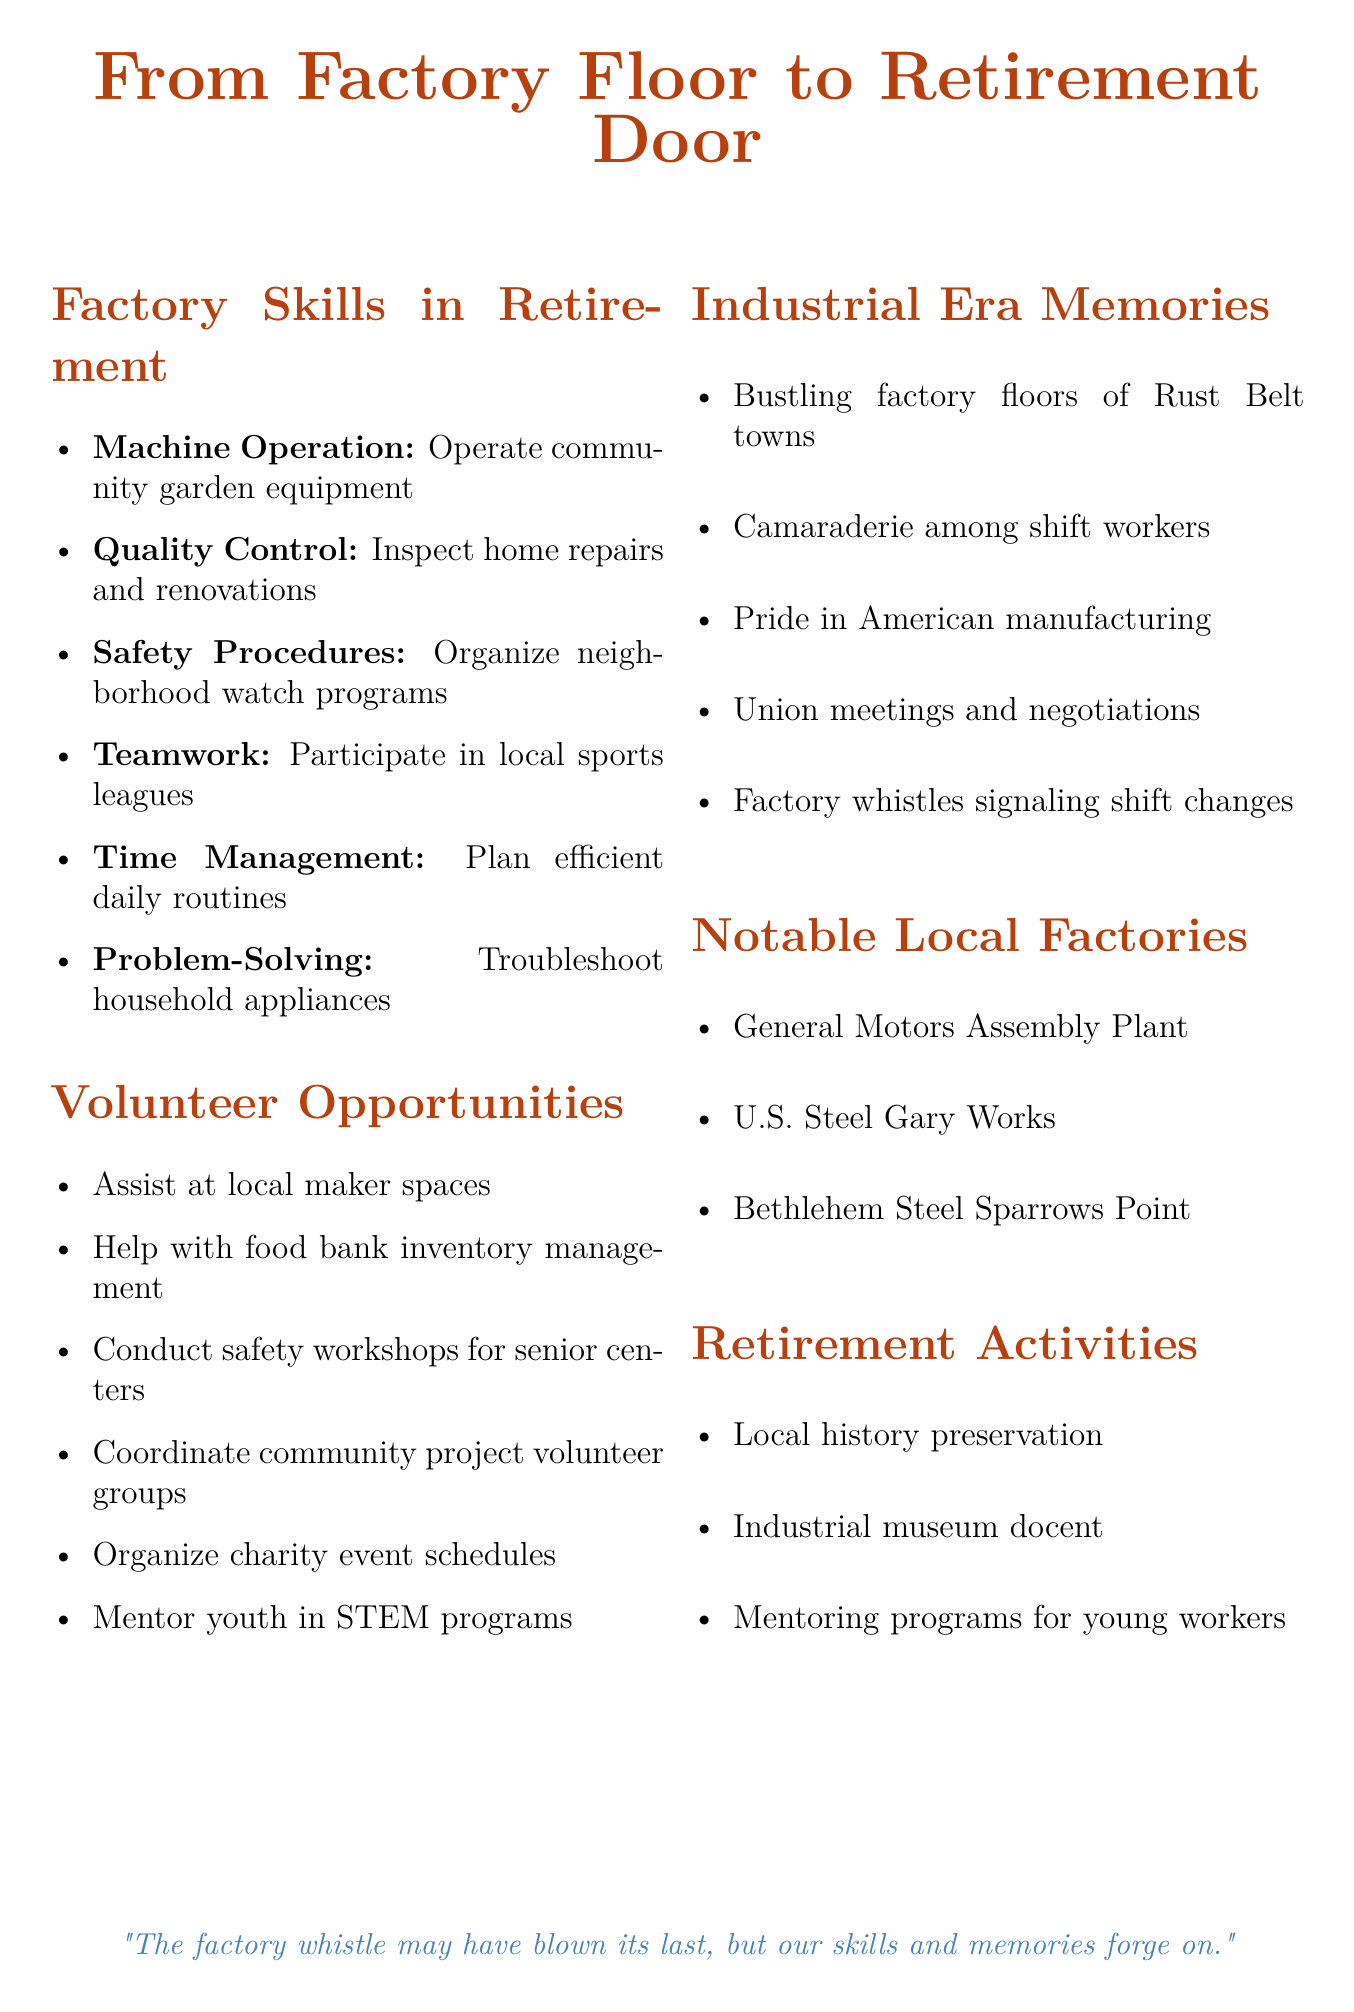What skill involves the use of equipment in community gardens? The skill that involves using equipment in community gardens is "Machine Operation."
Answer: Machine Operation What is one application of Quality Control in retirement? One application of Quality Control in retirement is "Inspecting home repairs and renovations."
Answer: Inspecting home repairs and renovations What type of workshops can seniors attend related to Safety Procedures? Seniors can attend "safety workshops" related to Safety Procedures.
Answer: safety workshops Which skill relates to helping coordinate volunteer groups? The skill that relates to coordinating volunteer groups is "Teamwork."
Answer: Teamwork Name a notable factory mentioned in the document. One notable factory mentioned is "U.S. Steel Gary Works."
Answer: U.S. Steel Gary Works How many skills are listed under Factory Skills in the document? The document lists a total of six skills under Factory Skills.
Answer: six What is the main theme captured in the quote at the end of the document? The quote reflects on the enduring legacy of skills and memories from the factory era.
Answer: enduring legacy of skills and memories What retirement activity involves historical work? The retirement activity that involves historical work is "Local history preservation."
Answer: Local history preservation Which volunteer opportunity involves inventory management? The volunteer opportunity that involves inventory management is "Helping with food bank inventory management."
Answer: Helping with food bank inventory management 